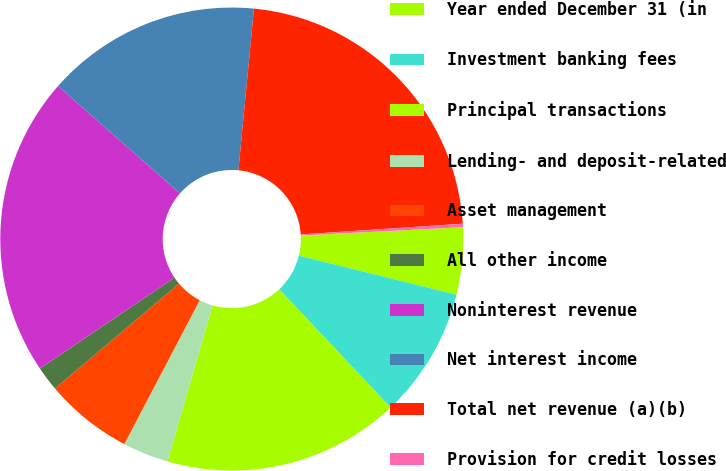<chart> <loc_0><loc_0><loc_500><loc_500><pie_chart><fcel>Year ended December 31 (in<fcel>Investment banking fees<fcel>Principal transactions<fcel>Lending- and deposit-related<fcel>Asset management<fcel>All other income<fcel>Noninterest revenue<fcel>Net interest income<fcel>Total net revenue (a)(b)<fcel>Provision for credit losses<nl><fcel>4.68%<fcel>9.11%<fcel>16.51%<fcel>3.2%<fcel>6.15%<fcel>1.72%<fcel>20.94%<fcel>15.03%<fcel>22.42%<fcel>0.24%<nl></chart> 